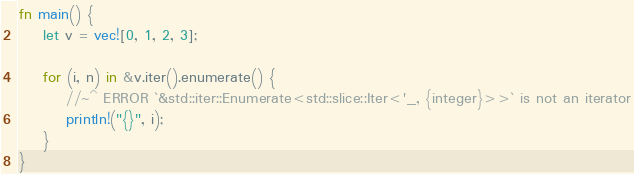Convert code to text. <code><loc_0><loc_0><loc_500><loc_500><_Rust_>fn main() {
    let v = vec![0, 1, 2, 3];

    for (i, n) in &v.iter().enumerate() {
        //~^ ERROR `&std::iter::Enumerate<std::slice::Iter<'_, {integer}>>` is not an iterator
        println!("{}", i);
    }
}
</code> 